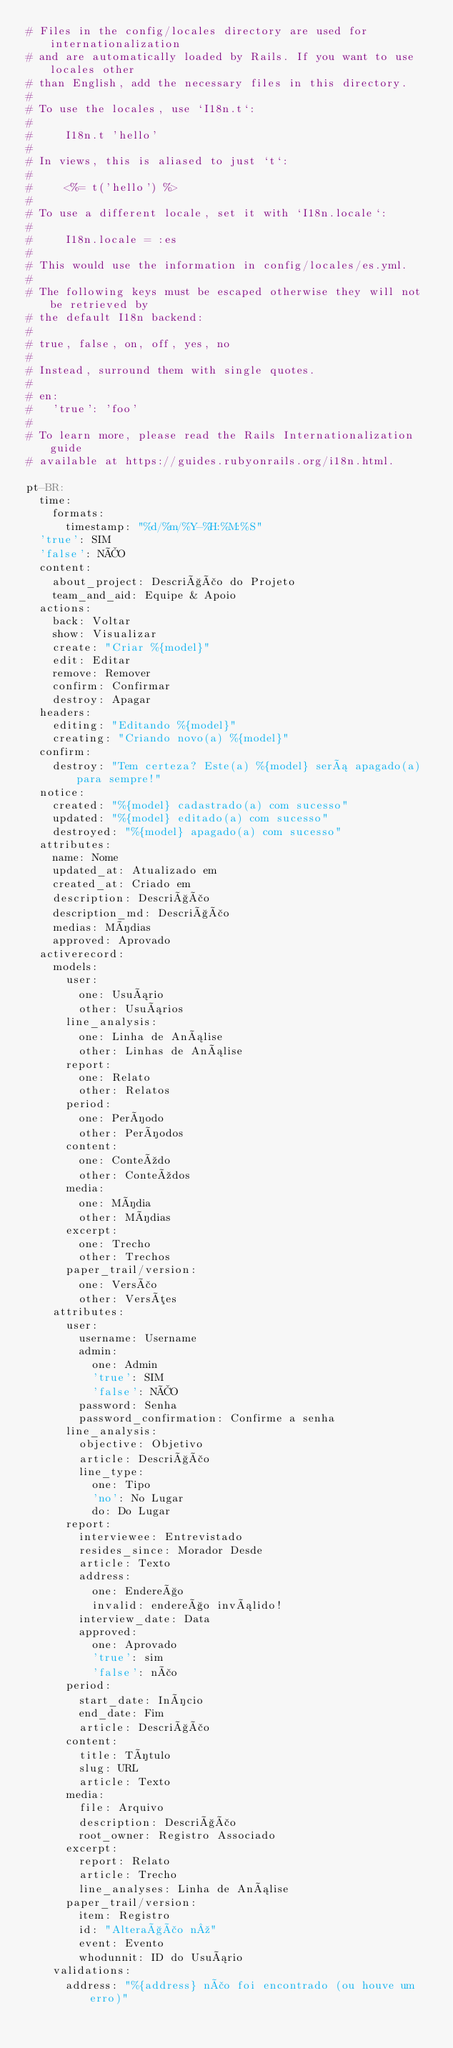Convert code to text. <code><loc_0><loc_0><loc_500><loc_500><_YAML_># Files in the config/locales directory are used for internationalization
# and are automatically loaded by Rails. If you want to use locales other
# than English, add the necessary files in this directory.
#
# To use the locales, use `I18n.t`:
#
#     I18n.t 'hello'
#
# In views, this is aliased to just `t`:
#
#     <%= t('hello') %>
#
# To use a different locale, set it with `I18n.locale`:
#
#     I18n.locale = :es
#
# This would use the information in config/locales/es.yml.
#
# The following keys must be escaped otherwise they will not be retrieved by
# the default I18n backend:
#
# true, false, on, off, yes, no
#
# Instead, surround them with single quotes.
#
# en:
#   'true': 'foo'
#
# To learn more, please read the Rails Internationalization guide
# available at https://guides.rubyonrails.org/i18n.html.

pt-BR:
  time:
    formats:
      timestamp: "%d/%m/%Y-%H:%M:%S"
  'true': SIM
  'false': NÃO
  content:
    about_project: Descrição do Projeto
    team_and_aid: Equipe & Apoio
  actions:
    back: Voltar
    show: Visualizar
    create: "Criar %{model}"
    edit: Editar
    remove: Remover
    confirm: Confirmar
    destroy: Apagar
  headers:
    editing: "Editando %{model}"
    creating: "Criando novo(a) %{model}"
  confirm:
    destroy: "Tem certeza? Este(a) %{model} será apagado(a) para sempre!"
  notice:
    created: "%{model} cadastrado(a) com sucesso"
    updated: "%{model} editado(a) com sucesso"
    destroyed: "%{model} apagado(a) com sucesso"
  attributes:
    name: Nome
    updated_at: Atualizado em
    created_at: Criado em
    description: Descrição
    description_md: Descrição
    medias: Mídias
    approved: Aprovado
  activerecord:
    models:
      user:
        one: Usuário
        other: Usuários
      line_analysis:
        one: Linha de Análise
        other: Linhas de Análise
      report:
        one: Relato
        other: Relatos
      period:
        one: Período
        other: Períodos
      content:
        one: Conteúdo
        other: Conteúdos
      media:
        one: Mídia
        other: Mídias
      excerpt:
        one: Trecho
        other: Trechos
      paper_trail/version:
        one: Versão
        other: Versões
    attributes:
      user:
        username: Username
        admin:
          one: Admin
          'true': SIM
          'false': NÃO
        password: Senha
        password_confirmation: Confirme a senha
      line_analysis:
        objective: Objetivo
        article: Descrição
        line_type:
          one: Tipo
          'no': No Lugar
          do: Do Lugar
      report:
        interviewee: Entrevistado
        resides_since: Morador Desde
        article: Texto
        address:
          one: Endereço
          invalid: endereço inválido!
        interview_date: Data
        approved:
          one: Aprovado
          'true': sim
          'false': não
      period:
        start_date: Início
        end_date: Fim
        article: Descrição
      content:
        title: Título
        slug: URL
        article: Texto
      media:
        file: Arquivo
        description: Descrição
        root_owner: Registro Associado
      excerpt:
        report: Relato
        article: Trecho
        line_analyses: Linha de Análise
      paper_trail/version:
        item: Registro
        id: "Alteração nº"
        event: Evento
        whodunnit: ID do Usuário
    validations:
      address: "%{address} não foi encontrado (ou houve um erro)"
</code> 